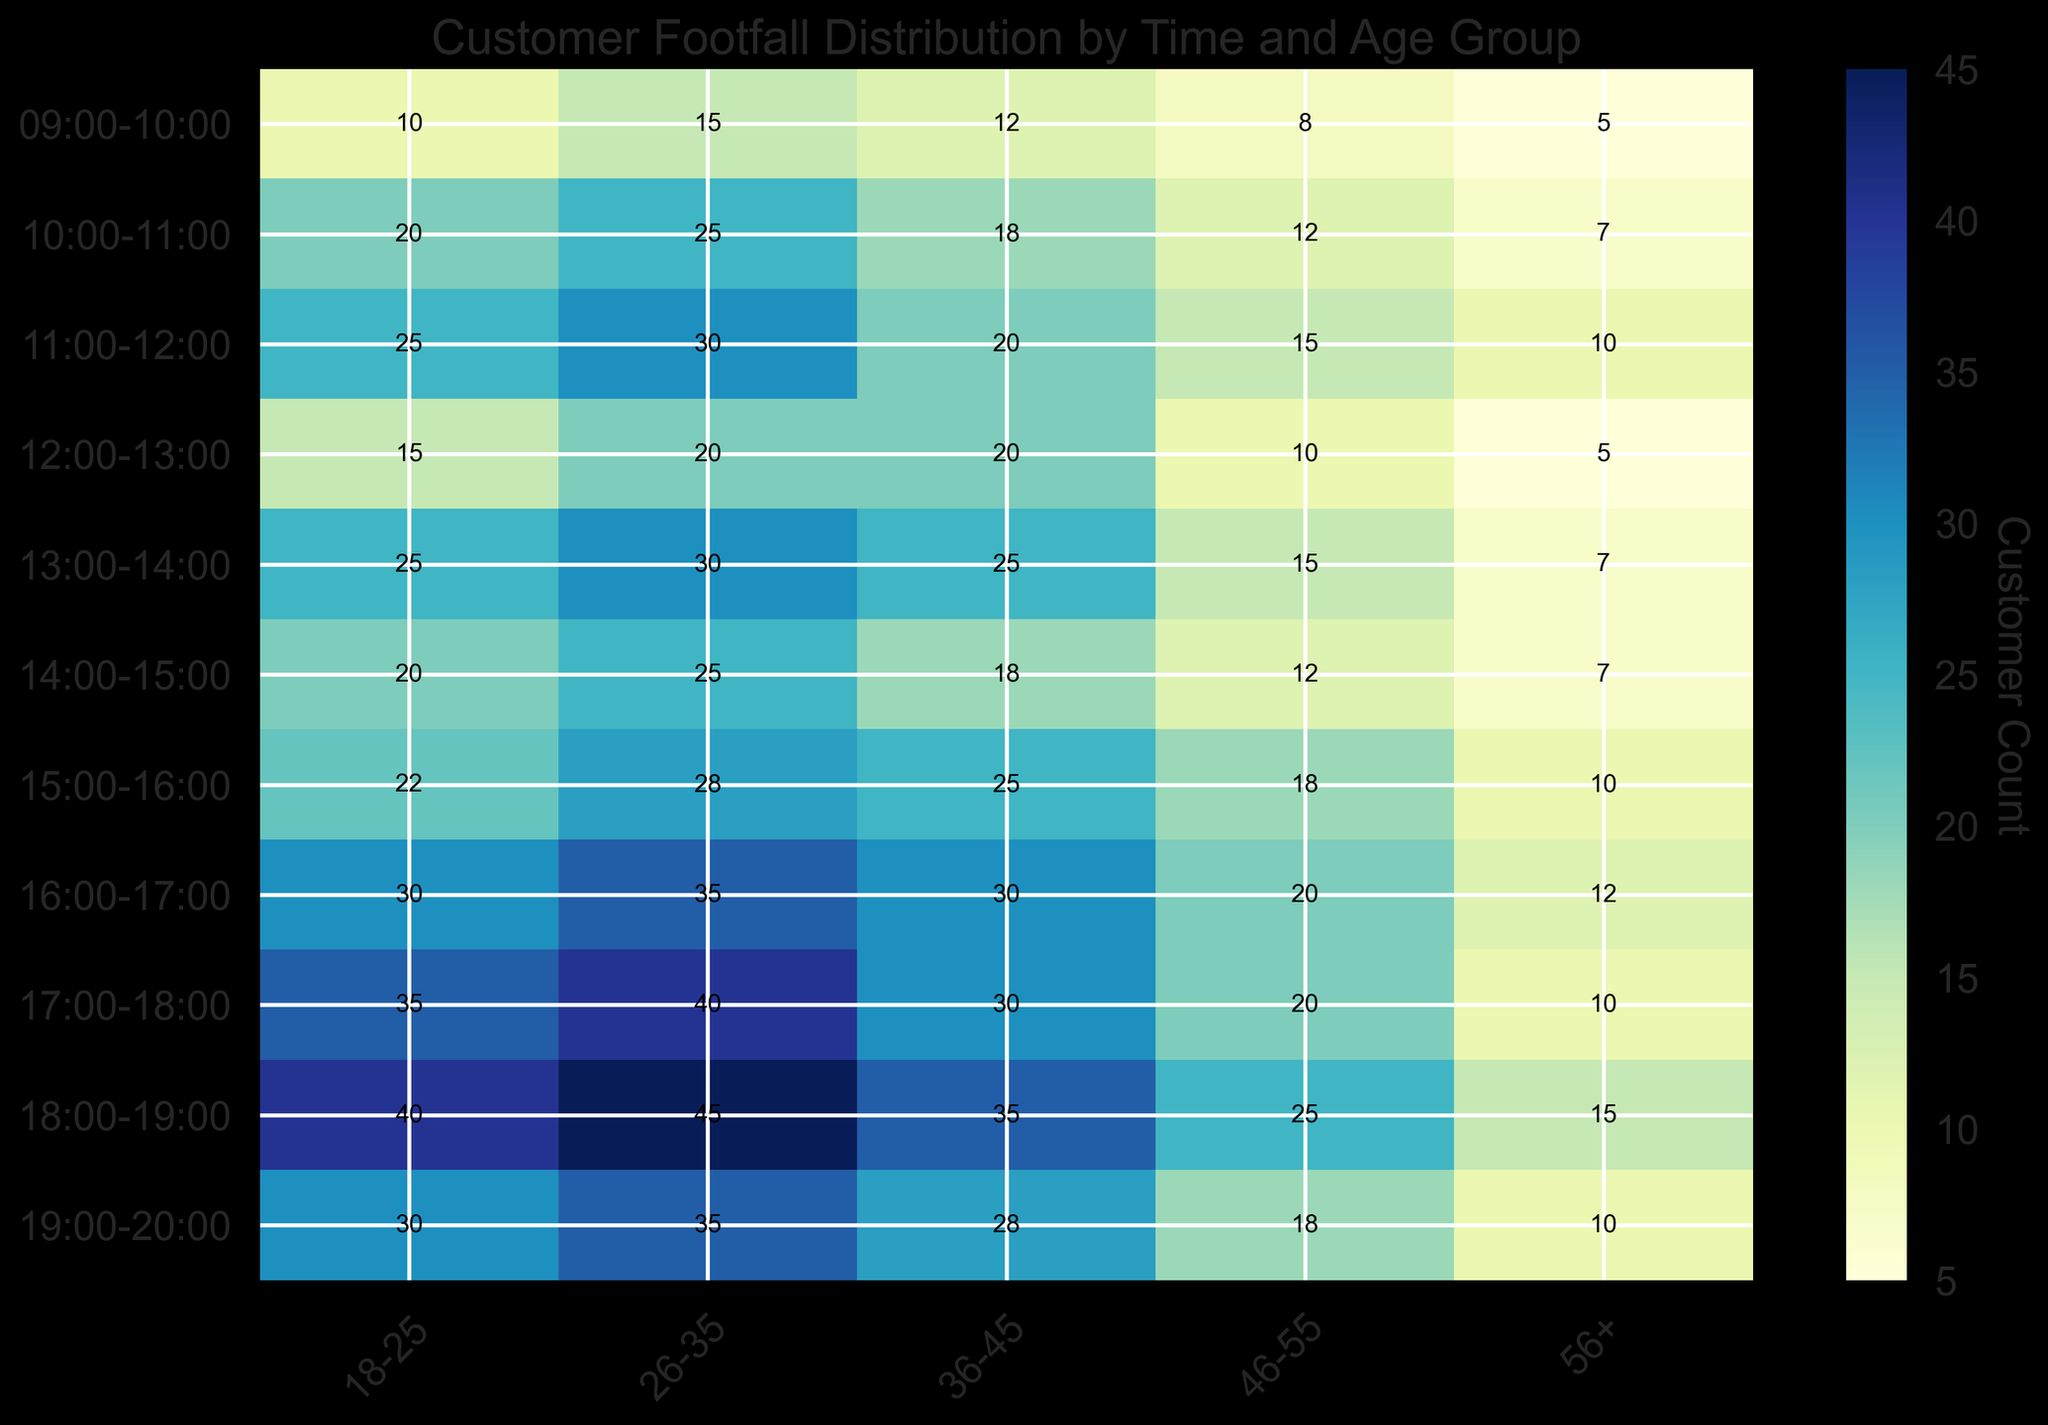What's the peak footfall time for the 26-35 age group? To identify the peak footfall time for the 26-35 age group, look for the highest value in the respective column. The highest footfall for the 26-35 age group is 45, which occurs from 18:00-19:00.
Answer: 18:00-19:00 Which age group has the least footfall during 09:00-10:00? To find the age group with the least footfall during 09:00-10:00, examine that row and identify the smallest value. The smallest value is 5, which corresponds to the 56+ age group.
Answer: 56+ What is the sum of footfall for the 18-25 age group from 17:00-20:00? Sum the values for the 18-25 age group from 17:00-20:00: 35 (17:00-18:00) + 40 (18:00-19:00) + 30 (19:00-20:00) = 105.
Answer: 105 How does the footfall for the 46-55 age group vary between 15:00-16:00 and 16:00-17:00? Compare the values for the 46-55 age group between 15:00-16:00 and 16:00-17:00. The footfall increases from 18 to 20.
Answer: Increases by 2 Which time slot has the most uniform distribution of footfall across all age groups? The most uniform distribution will have values that are close to each other. During 12:00-13:00, the footfall values across all age groups are relatively close (15, 20, 20, 10, 5), suggesting uniformity.
Answer: 12:00-13:00 What is the average footfall for the 36-45 age group throughout the day? Sum the total footfall for the 36-45 age group across all time slots and divide by the total number of periods: (12 + 18 + 20 + 25 + 18 + 25 + 30 + 30 + 35 + 28) / 10 = 24.1.
Answer: 24.1 During which time slot does the 18-25 age group show a higher footfall compared to the 56+ age group by at least 30? Calculate the difference between 18-25 and 56+ age groups for each time slot. The only slot with a difference of at least 30 is 18:00-19:00: 40 - 15 = 25.
Answer: None Which age group shows the highest increase in footfall from 10:00-11:00 to 11:00-12:00? Calculate the difference for each age group between 10:00-11:00 and 11:00-12:00. The 56+ group increases by 3 (7 to 10), the smallest among increases. The 18-25 group increases from 20 to 25, and the 26-35 group from 25 to 30, both showing less than the increase in the other age groups.
Answer: 56+ During which time slot does the 26-35 age group have the largest difference in footfall compared to the 46-55 age group? Compute the difference for each time slot. The largest difference is at 18:00-19:00 with a difference of 45 (26-35) - 25 (46-55) = 20.
Answer: 18:00-19:00 